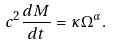<formula> <loc_0><loc_0><loc_500><loc_500>c ^ { 2 } \frac { d M } { d t } = \kappa \Omega ^ { \alpha } .</formula> 